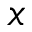Convert formula to latex. <formula><loc_0><loc_0><loc_500><loc_500>x</formula> 